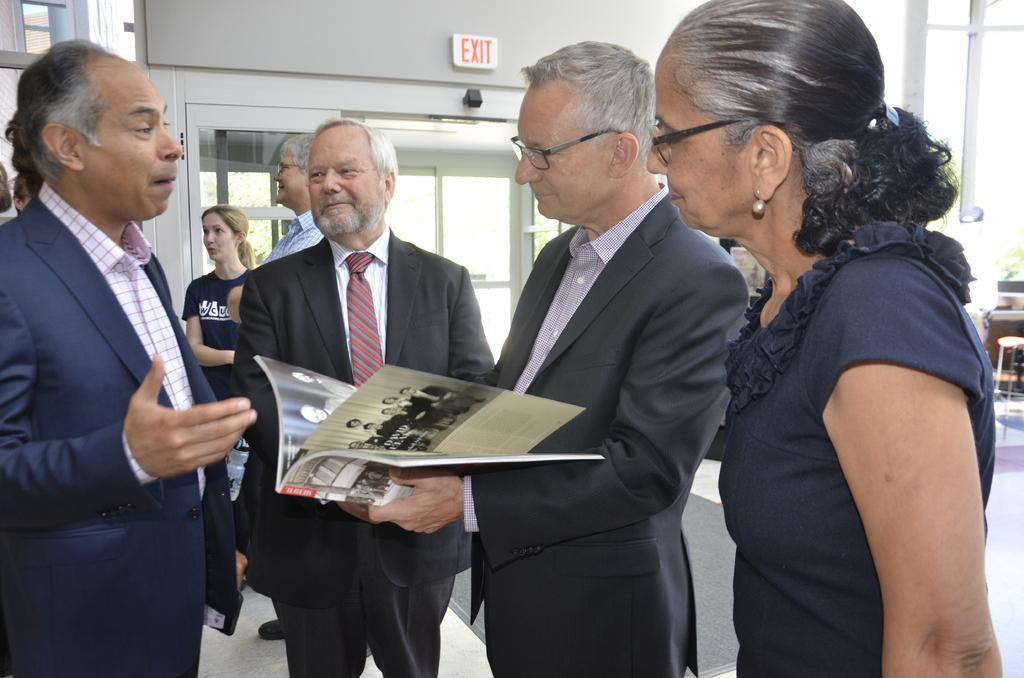Please provide a concise description of this image. In this image we can see a few people standing and among them one person holding a book and in front of him there is a person talking. In the background, we can see the wall with a board and there is some text on it. 